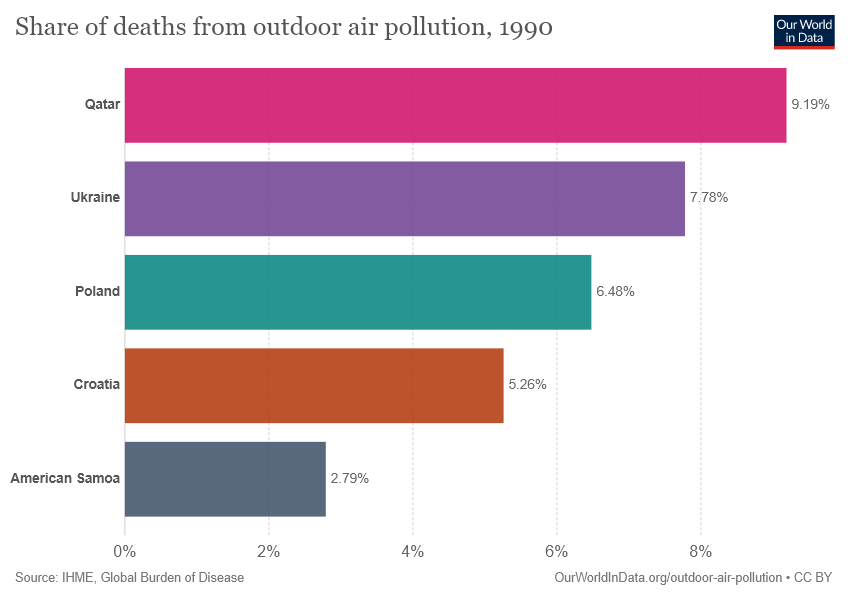Indicate a few pertinent items in this graphic. The value for Poland is 0.0648... The ratio between American Samoa and Qatar is 0.30359... 